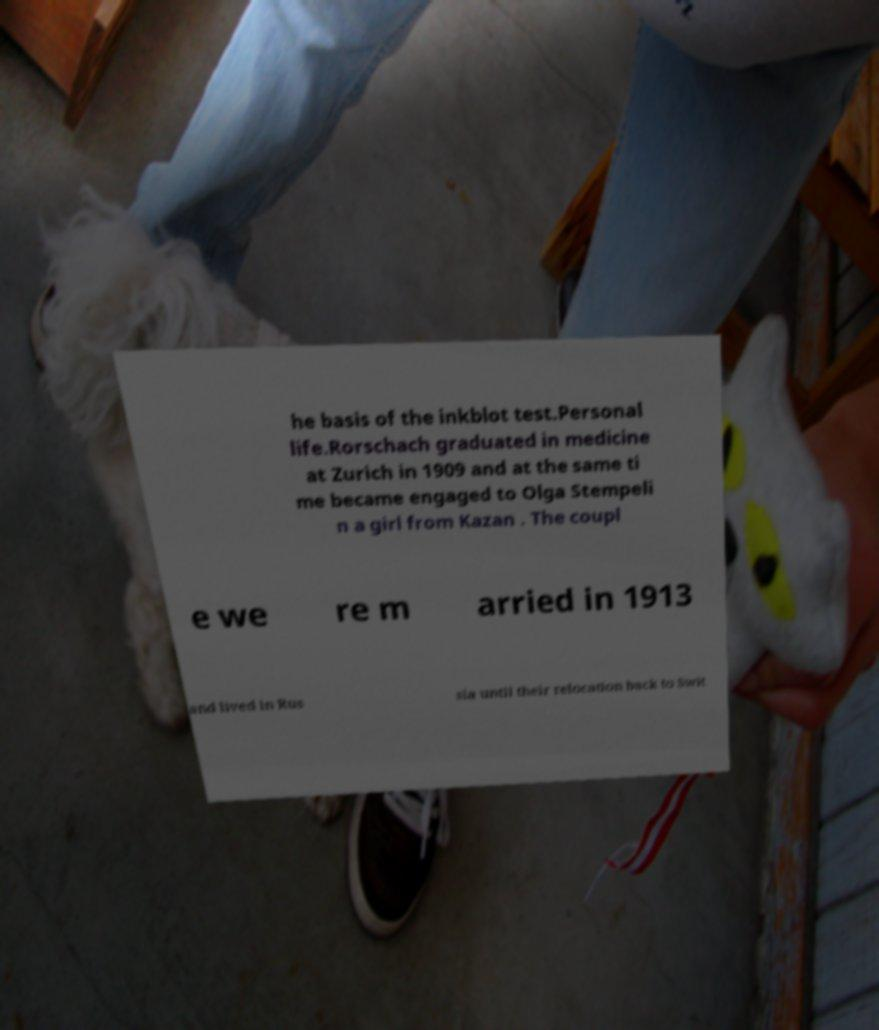Please identify and transcribe the text found in this image. he basis of the inkblot test.Personal life.Rorschach graduated in medicine at Zurich in 1909 and at the same ti me became engaged to Olga Stempeli n a girl from Kazan . The coupl e we re m arried in 1913 and lived in Rus sia until their relocation back to Swit 